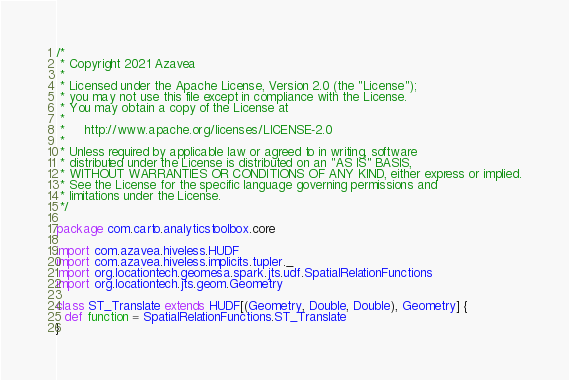<code> <loc_0><loc_0><loc_500><loc_500><_Scala_>/*
 * Copyright 2021 Azavea
 *
 * Licensed under the Apache License, Version 2.0 (the "License");
 * you may not use this file except in compliance with the License.
 * You may obtain a copy of the License at
 *
 *     http://www.apache.org/licenses/LICENSE-2.0
 *
 * Unless required by applicable law or agreed to in writing, software
 * distributed under the License is distributed on an "AS IS" BASIS,
 * WITHOUT WARRANTIES OR CONDITIONS OF ANY KIND, either express or implied.
 * See the License for the specific language governing permissions and
 * limitations under the License.
 */

package com.carto.analyticstoolbox.core

import com.azavea.hiveless.HUDF
import com.azavea.hiveless.implicits.tupler._
import org.locationtech.geomesa.spark.jts.udf.SpatialRelationFunctions
import org.locationtech.jts.geom.Geometry

class ST_Translate extends HUDF[(Geometry, Double, Double), Geometry] {
  def function = SpatialRelationFunctions.ST_Translate
}
</code> 